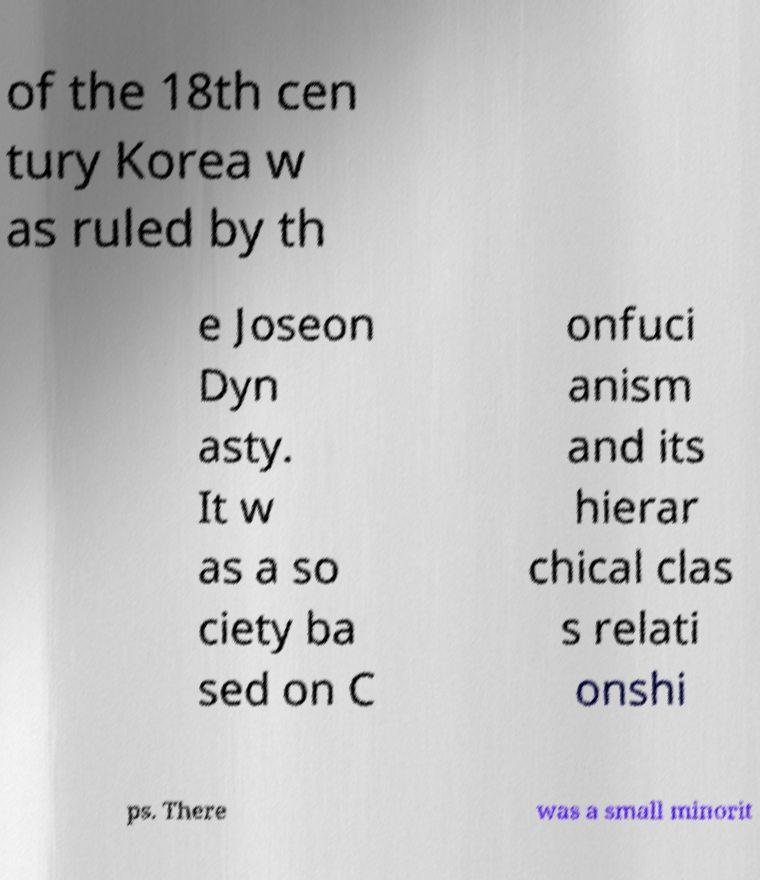I need the written content from this picture converted into text. Can you do that? of the 18th cen tury Korea w as ruled by th e Joseon Dyn asty. It w as a so ciety ba sed on C onfuci anism and its hierar chical clas s relati onshi ps. There was a small minorit 